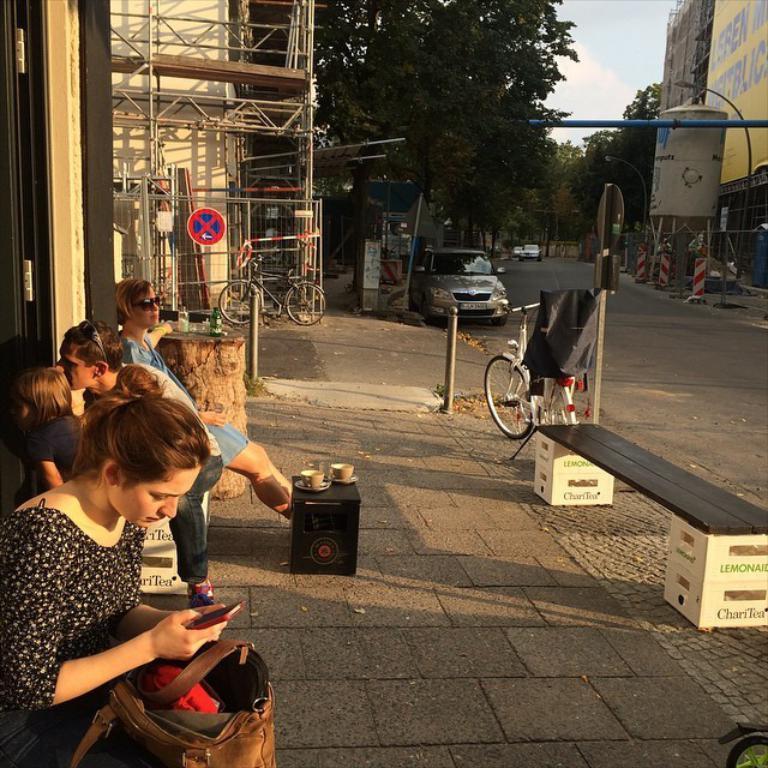Describe this image in one or two sentences. On the left side of the image we can see buildings, iron rods, cycle and persons. On the right side of the image we can see buildings, vehicles and road. In the background we can see trees, sky and clouds. 